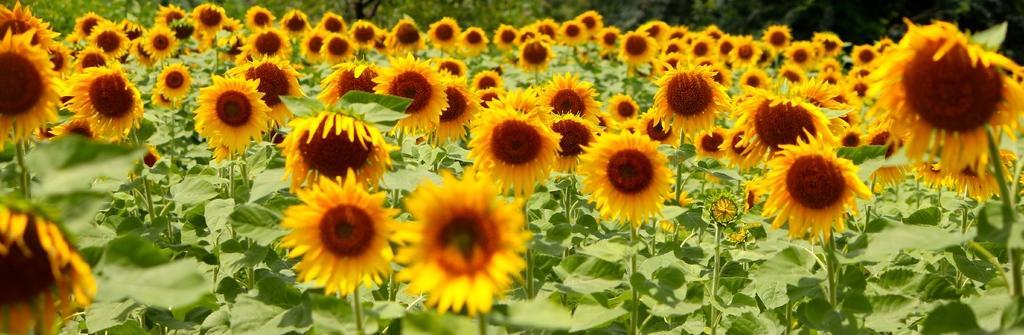Could you give a brief overview of what you see in this image? In this image, we can see plants along with flowers. 